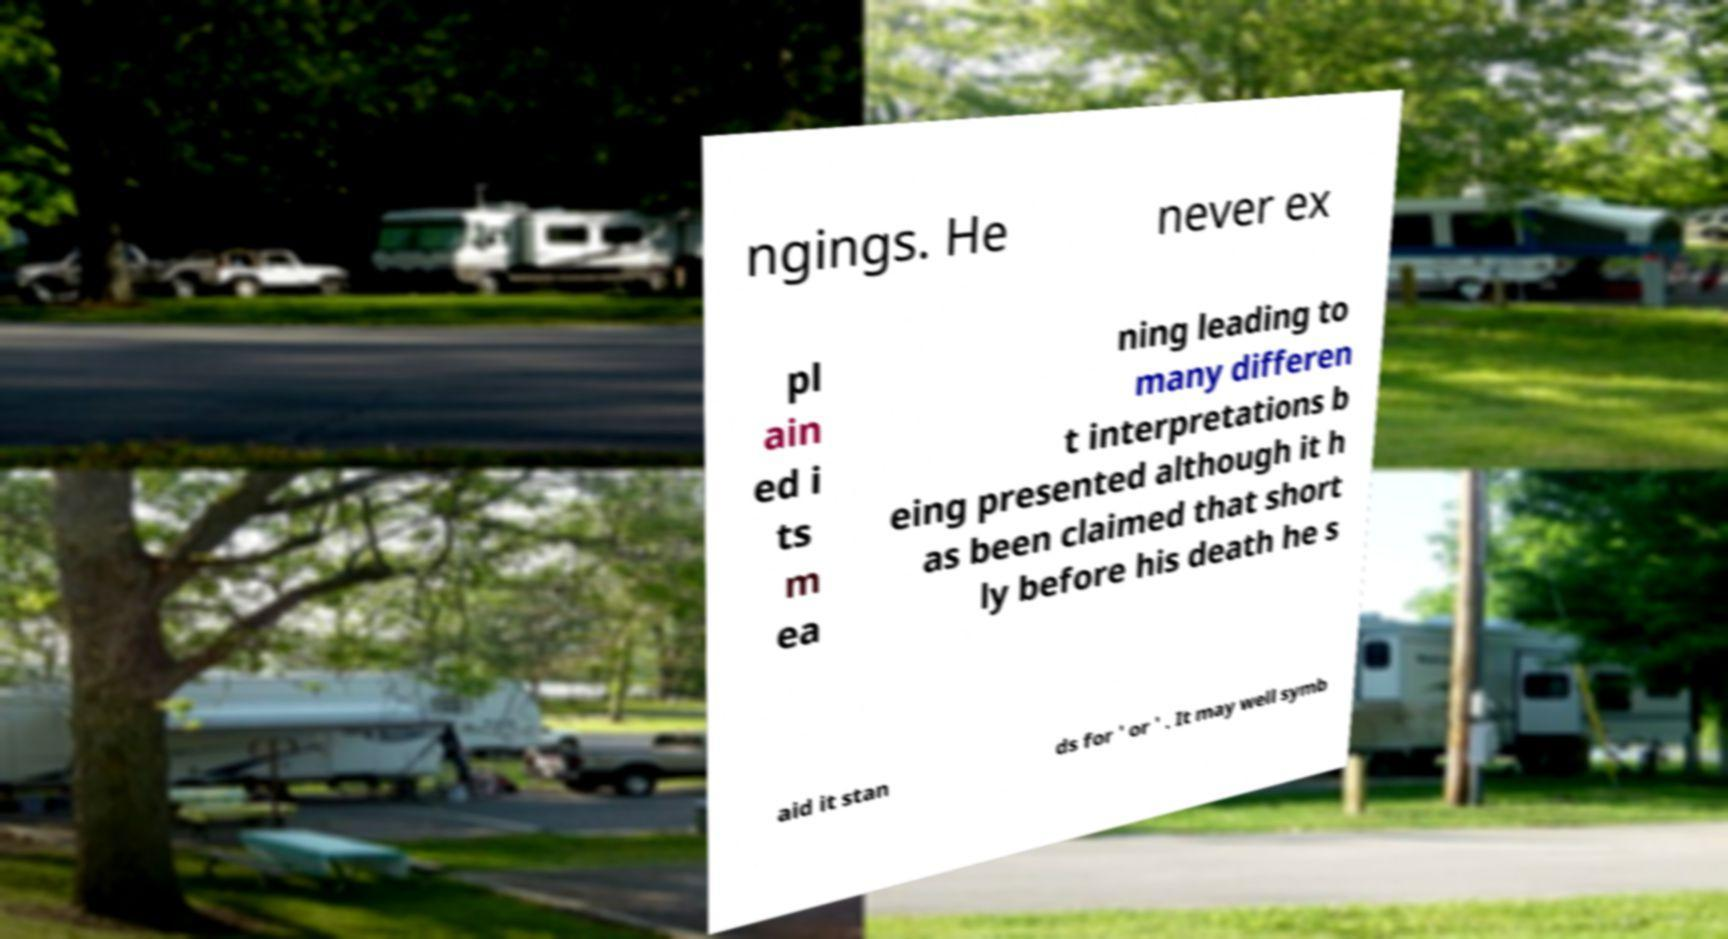I need the written content from this picture converted into text. Can you do that? ngings. He never ex pl ain ed i ts m ea ning leading to many differen t interpretations b eing presented although it h as been claimed that short ly before his death he s aid it stan ds for ' or ' . It may well symb 